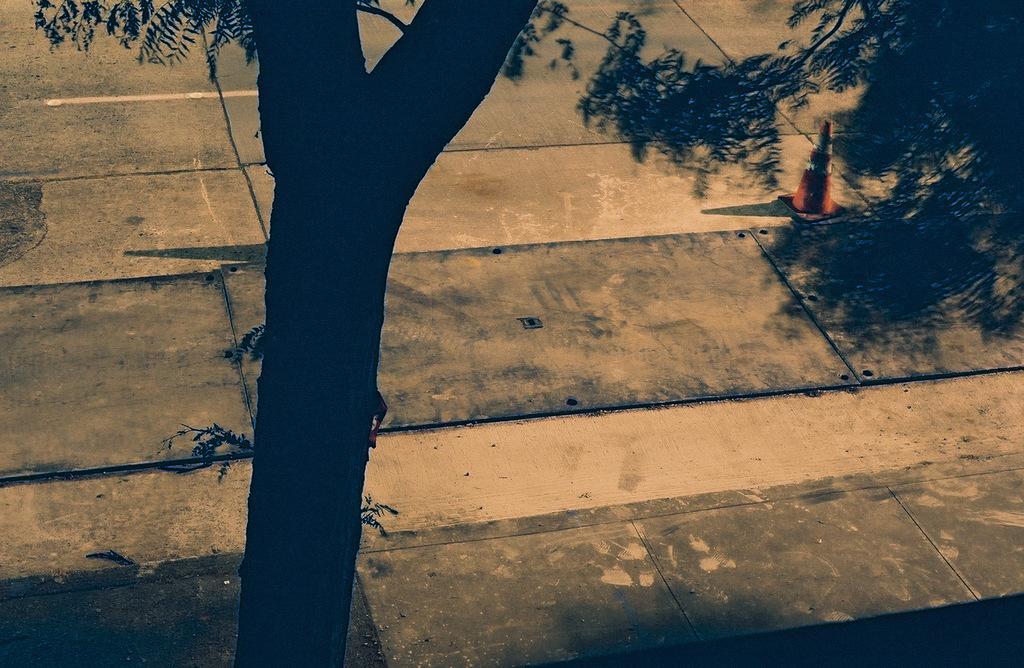How would you summarize this image in a sentence or two? There is a tree and a traffic cone. 